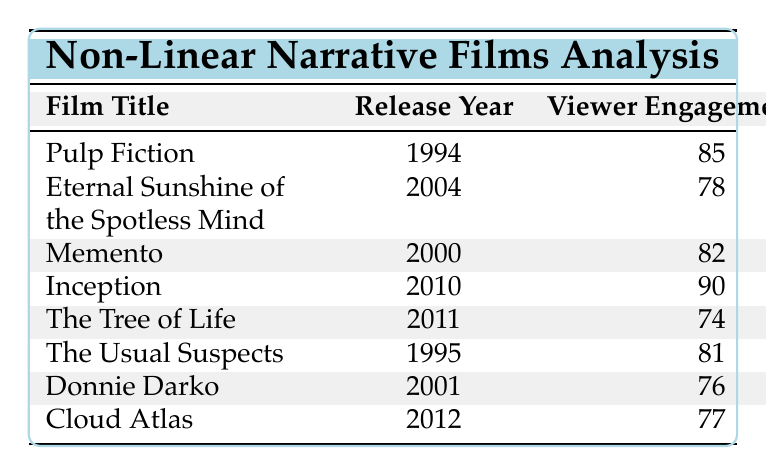What is the viewer engagement score for "Inception"? According to the table, under the column for viewer engagement score, "Inception" has a score of 90.
Answer: 90 Which film released in 2011 has the lowest viewer engagement score? The table shows that "The Tree of Life," released in 2011, has a viewer engagement score of 74, which is lower than the scores of other films from the same year.
Answer: The Tree of Life What is the total revenue generated by all the films listed? To find the total revenue, we sum all of the revenue values: 214 + 72 + 40 + 836 + 13 + 34 + 7 + 130 = 1346 million.
Answer: 1346 Is the viewer engagement score of "Donnie Darko" greater than 75? The viewer engagement score for "Donnie Darko" is 76, which is indeed greater than 75, confirming the statement is true.
Answer: Yes What is the average viewer engagement score of films released before 2000? The films released before 2000 are "Pulp Fiction" (85), "The Usual Suspects" (81), and "Memento" (82). The average score is (85 + 81 + 82) / 3 = 82.67.
Answer: 82.67 Which film has the highest revenue, and what is that revenue? The table indicates that "Inception" has the highest revenue at 836 million dollars.
Answer: Inception, 836 million Did "Cloud Atlas" generate more revenue than "The Tree of Life"? "Cloud Atlas" generated 130 million, while "The Tree of Life" generated only 13 million. Since 130 million is greater than 13 million, the statement is true.
Answer: Yes What is the difference in viewer engagement scores between "Pulp Fiction" and "Eternal Sunshine of the Spotless Mind"? The viewer engagement score for "Pulp Fiction" is 85, and for "Eternal Sunshine of the Spotless Mind," it is 78. The difference is 85 - 78 = 7.
Answer: 7 Which year saw the release of the film with the lowest viewer engagement score? "The Tree of Life," released in 2011, has the lowest viewer engagement score of 74 when compared to all other films listed.
Answer: 2011 